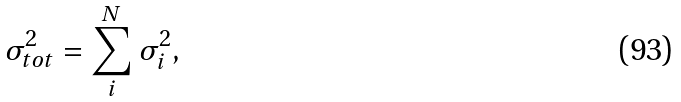<formula> <loc_0><loc_0><loc_500><loc_500>\sigma _ { t o t } ^ { 2 } = \sum _ { i } ^ { N } \sigma _ { i } ^ { 2 } ,</formula> 